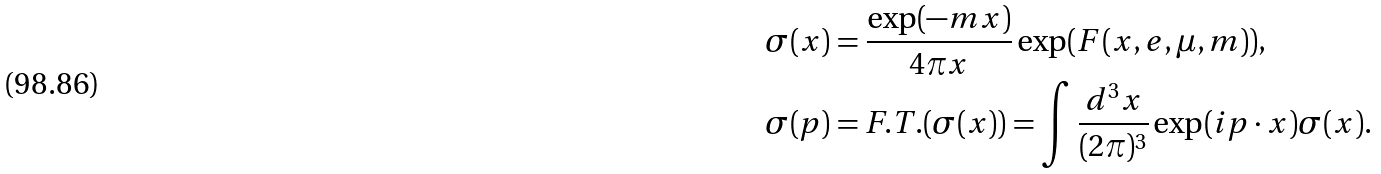<formula> <loc_0><loc_0><loc_500><loc_500>\sigma ( x ) & = \frac { \exp ( - m x ) } { 4 \pi x } \exp ( F ( x , e , \mu , m ) ) , \\ \sigma ( p ) & = F . T . ( \sigma ( x ) ) = \int \frac { d ^ { 3 } x } { ( 2 \pi ) ^ { 3 } } \exp ( i p \cdot x ) \sigma ( x ) .</formula> 